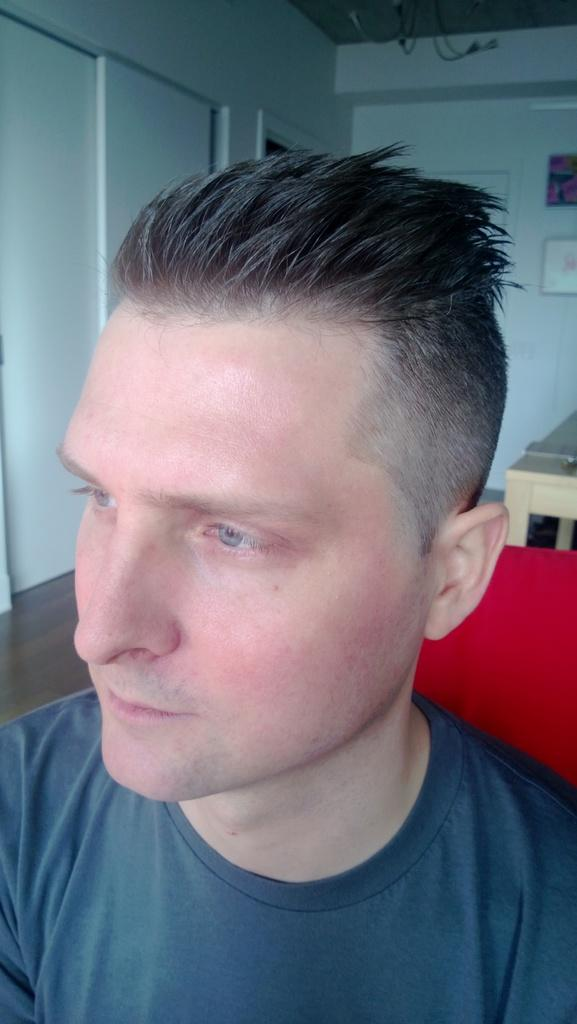What is present in the image? There is a man in the image. What is the man wearing? The man is wearing a t-shirt. What piece of furniture is in the image? There is a table in the image. What is visible on the wall in the image? There is something on the wall in the image. How many books can be seen on the wall in the image? There is no mention of books in the image; only the presence of a man, a t-shirt, a table, and something on the wall is mentioned. 